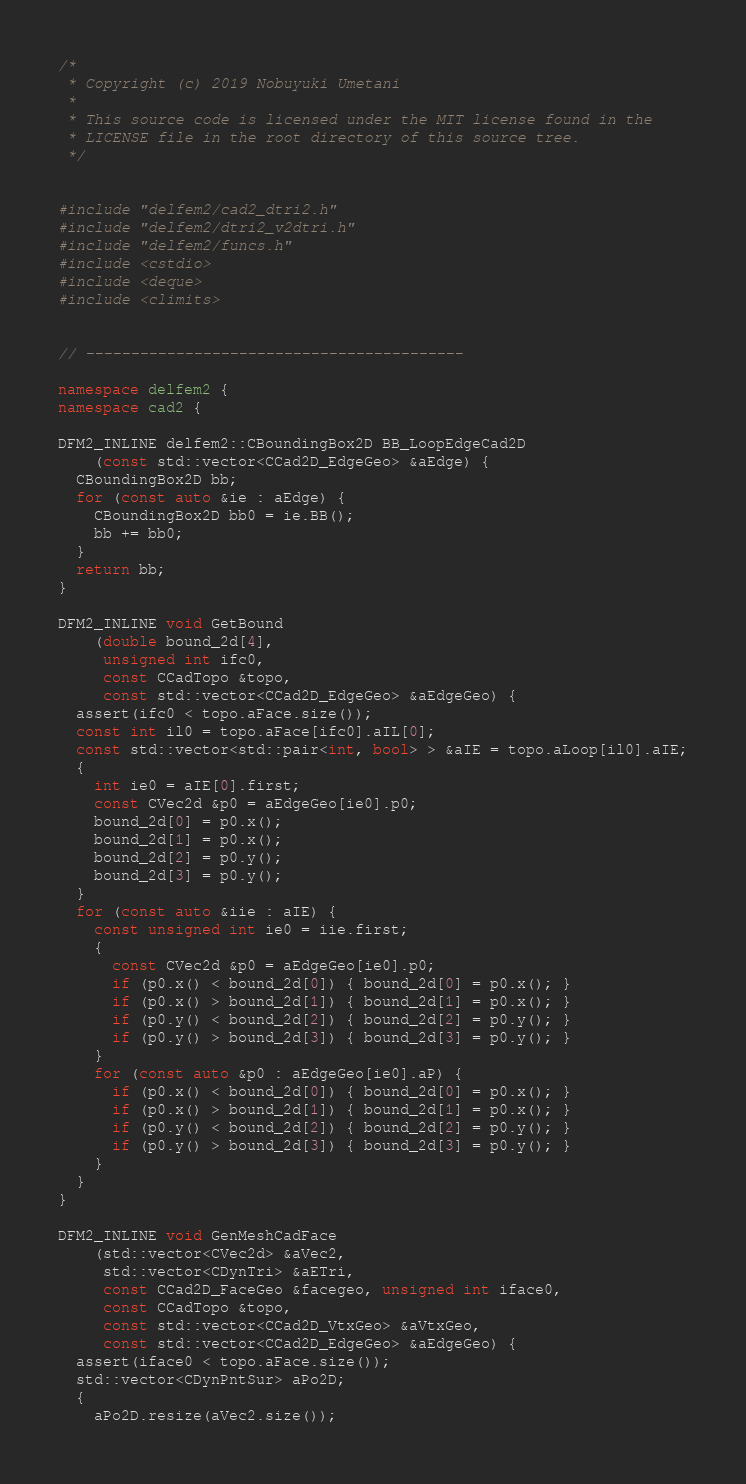Convert code to text. <code><loc_0><loc_0><loc_500><loc_500><_C++_>/*
 * Copyright (c) 2019 Nobuyuki Umetani
 *
 * This source code is licensed under the MIT license found in the
 * LICENSE file in the root directory of this source tree.
 */


#include "delfem2/cad2_dtri2.h"
#include "delfem2/dtri2_v2dtri.h"
#include "delfem2/funcs.h"
#include <cstdio>
#include <deque>
#include <climits>


// ------------------------------------------

namespace delfem2 {
namespace cad2 {

DFM2_INLINE delfem2::CBoundingBox2D BB_LoopEdgeCad2D
    (const std::vector<CCad2D_EdgeGeo> &aEdge) {
  CBoundingBox2D bb;
  for (const auto &ie : aEdge) {
    CBoundingBox2D bb0 = ie.BB();
    bb += bb0;
  }
  return bb;
}

DFM2_INLINE void GetBound
    (double bound_2d[4],
     unsigned int ifc0,
     const CCadTopo &topo,
     const std::vector<CCad2D_EdgeGeo> &aEdgeGeo) {
  assert(ifc0 < topo.aFace.size());
  const int il0 = topo.aFace[ifc0].aIL[0];
  const std::vector<std::pair<int, bool> > &aIE = topo.aLoop[il0].aIE;
  {
    int ie0 = aIE[0].first;
    const CVec2d &p0 = aEdgeGeo[ie0].p0;
    bound_2d[0] = p0.x();
    bound_2d[1] = p0.x();
    bound_2d[2] = p0.y();
    bound_2d[3] = p0.y();
  }
  for (const auto &iie : aIE) {
    const unsigned int ie0 = iie.first;
    {
      const CVec2d &p0 = aEdgeGeo[ie0].p0;
      if (p0.x() < bound_2d[0]) { bound_2d[0] = p0.x(); }
      if (p0.x() > bound_2d[1]) { bound_2d[1] = p0.x(); }
      if (p0.y() < bound_2d[2]) { bound_2d[2] = p0.y(); }
      if (p0.y() > bound_2d[3]) { bound_2d[3] = p0.y(); }
    }
    for (const auto &p0 : aEdgeGeo[ie0].aP) {
      if (p0.x() < bound_2d[0]) { bound_2d[0] = p0.x(); }
      if (p0.x() > bound_2d[1]) { bound_2d[1] = p0.x(); }
      if (p0.y() < bound_2d[2]) { bound_2d[2] = p0.y(); }
      if (p0.y() > bound_2d[3]) { bound_2d[3] = p0.y(); }
    }
  }
}

DFM2_INLINE void GenMeshCadFace
    (std::vector<CVec2d> &aVec2,
     std::vector<CDynTri> &aETri,
     const CCad2D_FaceGeo &facegeo, unsigned int iface0,
     const CCadTopo &topo,
     const std::vector<CCad2D_VtxGeo> &aVtxGeo,
     const std::vector<CCad2D_EdgeGeo> &aEdgeGeo) {
  assert(iface0 < topo.aFace.size());
  std::vector<CDynPntSur> aPo2D;
  {
    aPo2D.resize(aVec2.size());</code> 